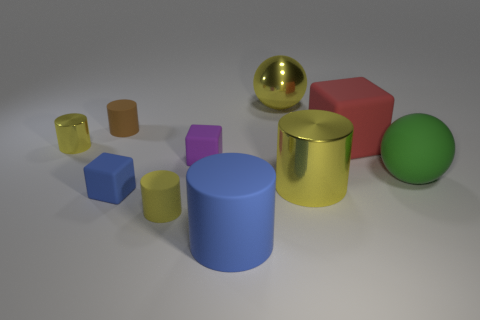Subtract all blue blocks. How many yellow cylinders are left? 3 Subtract all big yellow cylinders. How many cylinders are left? 4 Subtract all blue cylinders. How many cylinders are left? 4 Subtract all green cylinders. Subtract all blue balls. How many cylinders are left? 5 Subtract all cubes. How many objects are left? 7 Subtract all cylinders. Subtract all large yellow balls. How many objects are left? 4 Add 7 small shiny things. How many small shiny things are left? 8 Add 1 yellow shiny objects. How many yellow shiny objects exist? 4 Subtract 1 yellow spheres. How many objects are left? 9 